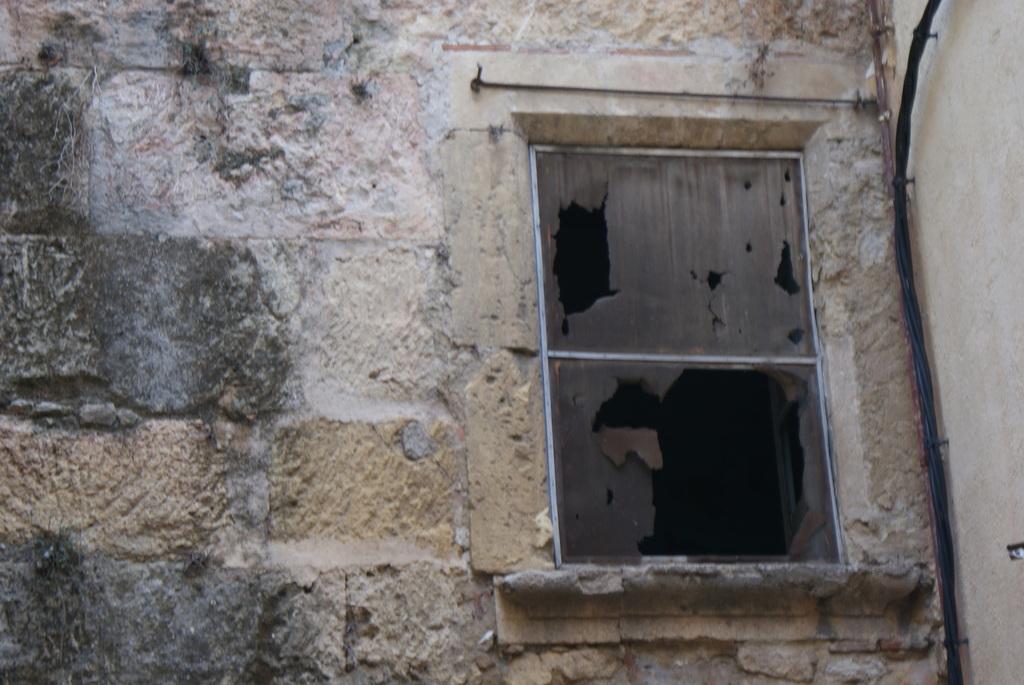Please provide a concise description of this image. In this image we can see wall, window and an object. On the right side we can see cables on the wall and there are nails. 